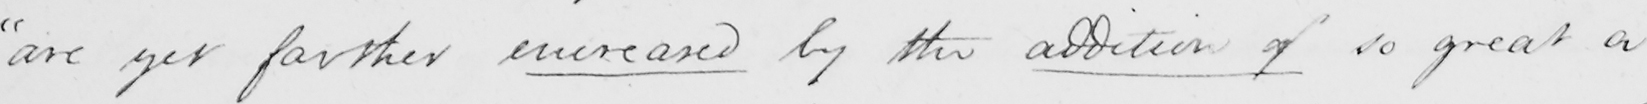Please provide the text content of this handwritten line. " are yet farther encreased by the addition of so great a 